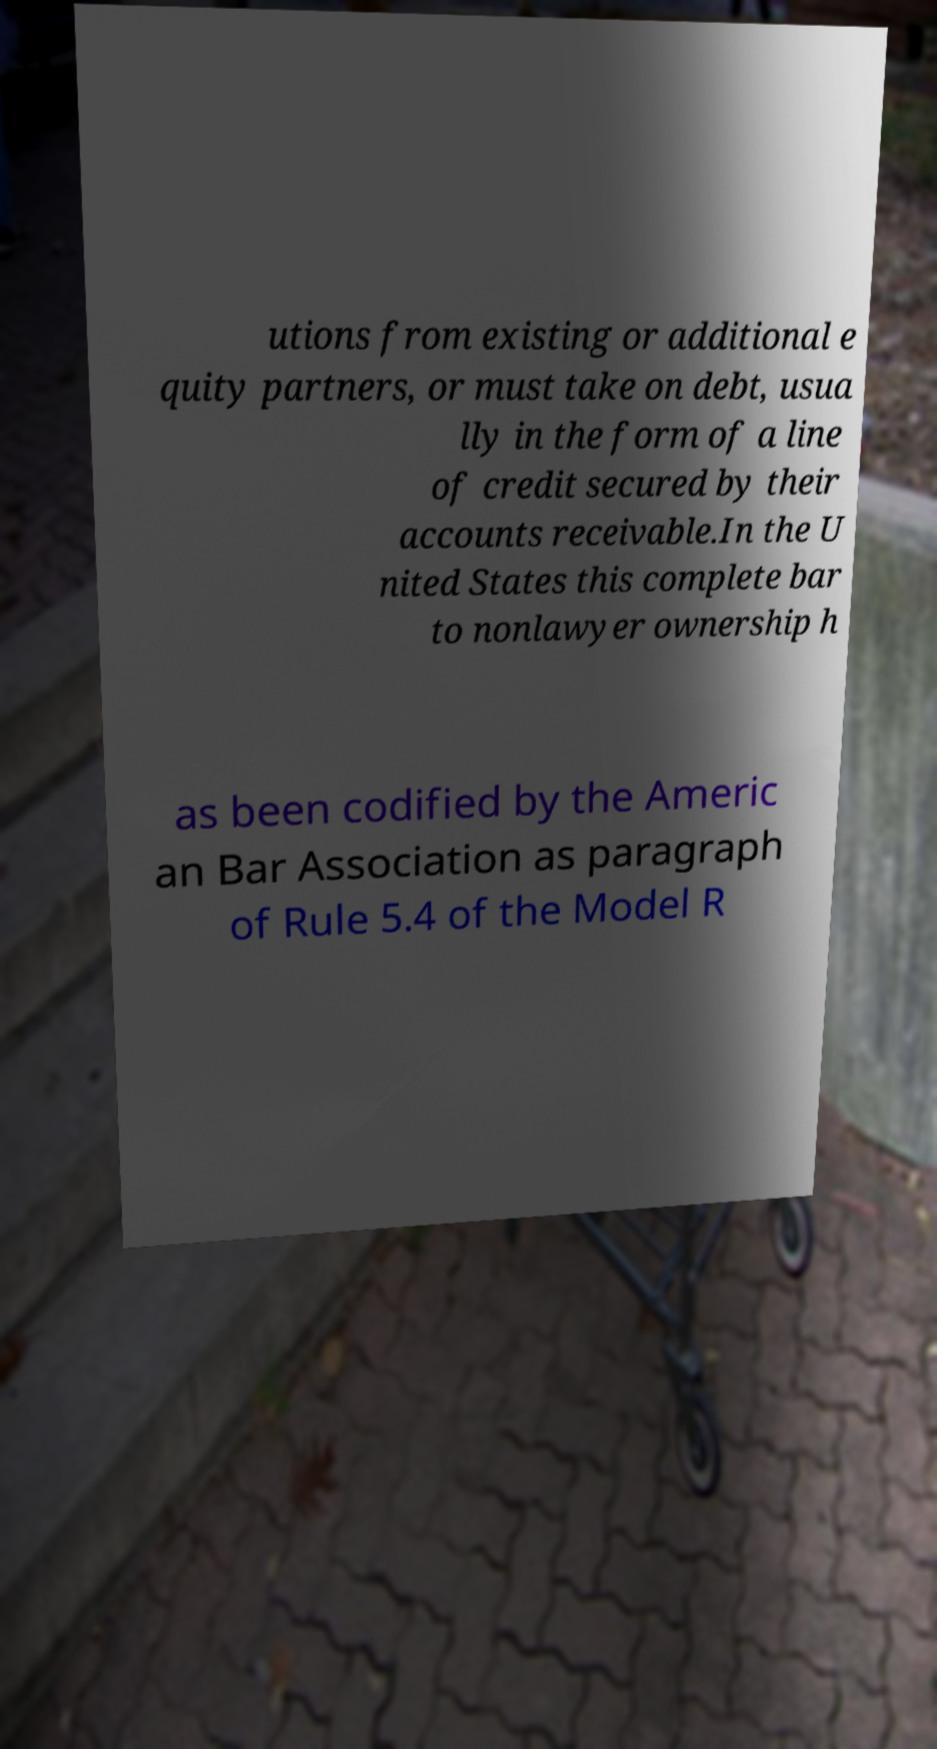Please read and relay the text visible in this image. What does it say? utions from existing or additional e quity partners, or must take on debt, usua lly in the form of a line of credit secured by their accounts receivable.In the U nited States this complete bar to nonlawyer ownership h as been codified by the Americ an Bar Association as paragraph of Rule 5.4 of the Model R 